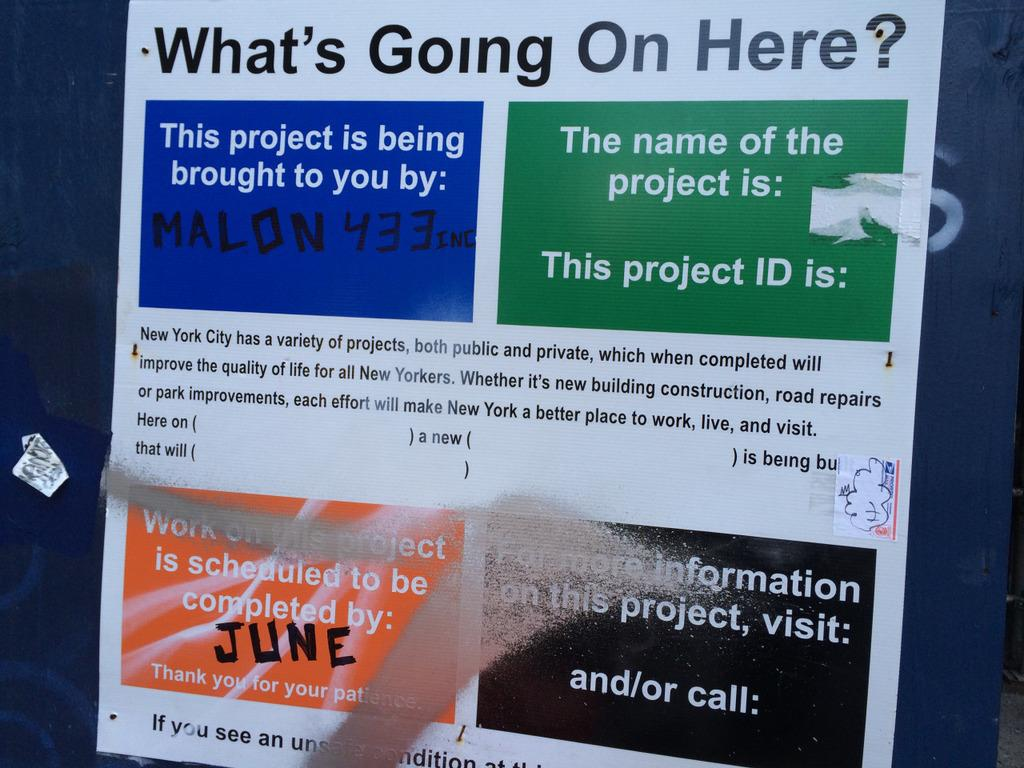Provide a one-sentence caption for the provided image. A sign posted for New Yorkers to complete projects that will improve the quality of life for all New Yorkers. 